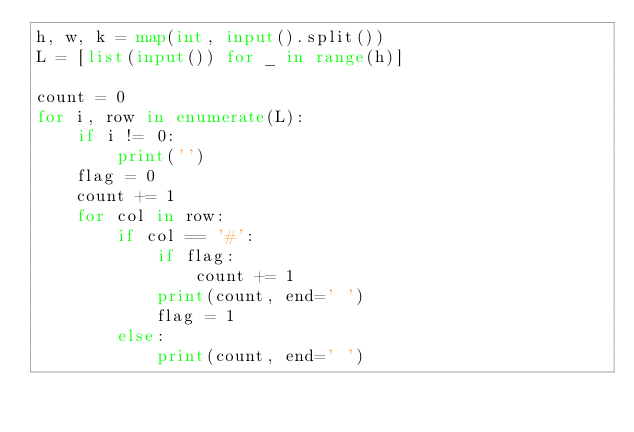Convert code to text. <code><loc_0><loc_0><loc_500><loc_500><_Python_>h, w, k = map(int, input().split())
L = [list(input()) for _ in range(h)]

count = 0
for i, row in enumerate(L):
    if i != 0:
        print('')
    flag = 0
    count += 1
    for col in row:
        if col == '#':
            if flag:
                count += 1
            print(count, end=' ')
            flag = 1
        else:
            print(count, end=' ')</code> 